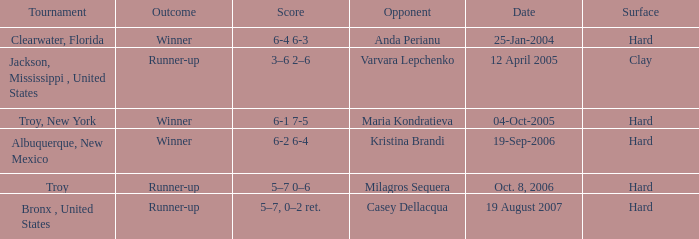What was the surface of the game that resulted in a final score of 6-1 7-5? Hard. 